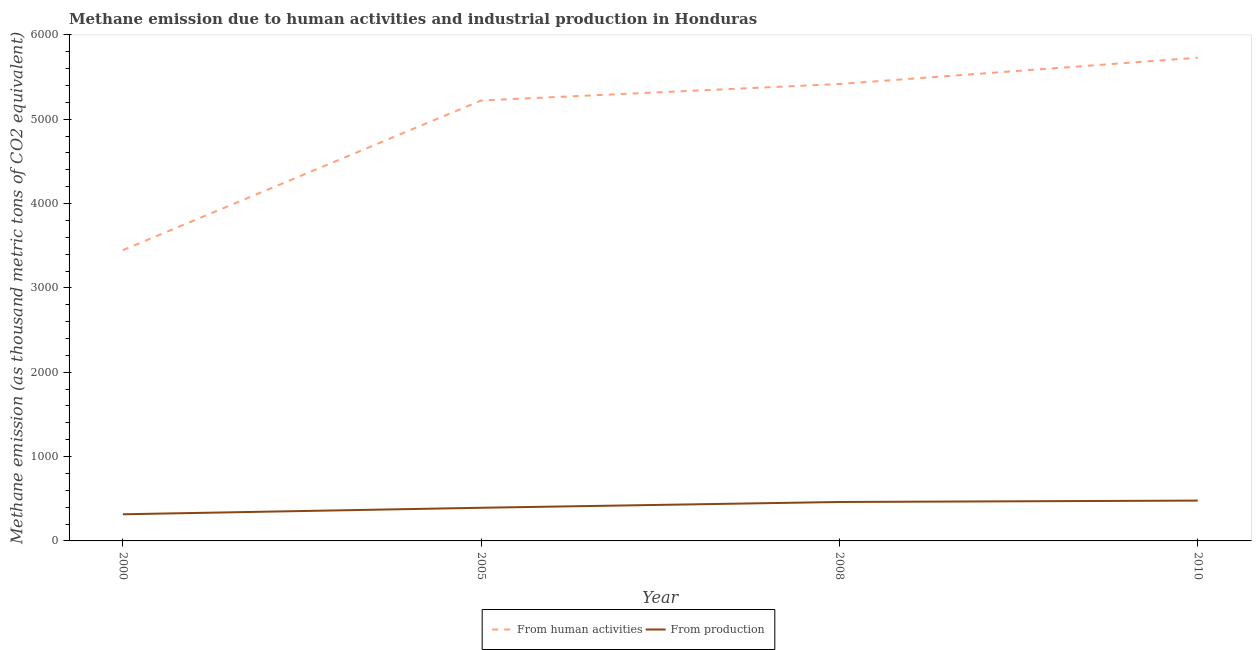How many different coloured lines are there?
Make the answer very short. 2. Does the line corresponding to amount of emissions generated from industries intersect with the line corresponding to amount of emissions from human activities?
Offer a very short reply. No. What is the amount of emissions from human activities in 2010?
Provide a short and direct response. 5729.7. Across all years, what is the maximum amount of emissions from human activities?
Give a very brief answer. 5729.7. Across all years, what is the minimum amount of emissions from human activities?
Offer a very short reply. 3447.7. In which year was the amount of emissions generated from industries minimum?
Offer a terse response. 2000. What is the total amount of emissions from human activities in the graph?
Offer a very short reply. 1.98e+04. What is the difference between the amount of emissions generated from industries in 2005 and that in 2008?
Ensure brevity in your answer.  -68.5. What is the difference between the amount of emissions from human activities in 2000 and the amount of emissions generated from industries in 2005?
Provide a succinct answer. 3054.5. What is the average amount of emissions from human activities per year?
Your answer should be compact. 4954.5. In the year 2010, what is the difference between the amount of emissions generated from industries and amount of emissions from human activities?
Offer a terse response. -5251.6. What is the ratio of the amount of emissions from human activities in 2000 to that in 2005?
Make the answer very short. 0.66. Is the amount of emissions from human activities in 2000 less than that in 2010?
Offer a very short reply. Yes. Is the difference between the amount of emissions from human activities in 2005 and 2010 greater than the difference between the amount of emissions generated from industries in 2005 and 2010?
Give a very brief answer. No. What is the difference between the highest and the second highest amount of emissions generated from industries?
Ensure brevity in your answer.  16.4. What is the difference between the highest and the lowest amount of emissions from human activities?
Ensure brevity in your answer.  2282. Is the amount of emissions generated from industries strictly less than the amount of emissions from human activities over the years?
Provide a succinct answer. Yes. How many lines are there?
Keep it short and to the point. 2. How many years are there in the graph?
Your response must be concise. 4. Are the values on the major ticks of Y-axis written in scientific E-notation?
Keep it short and to the point. No. Does the graph contain any zero values?
Offer a very short reply. No. Where does the legend appear in the graph?
Your response must be concise. Bottom center. How many legend labels are there?
Give a very brief answer. 2. How are the legend labels stacked?
Offer a very short reply. Horizontal. What is the title of the graph?
Your answer should be very brief. Methane emission due to human activities and industrial production in Honduras. Does "Quality of trade" appear as one of the legend labels in the graph?
Give a very brief answer. No. What is the label or title of the X-axis?
Keep it short and to the point. Year. What is the label or title of the Y-axis?
Give a very brief answer. Methane emission (as thousand metric tons of CO2 equivalent). What is the Methane emission (as thousand metric tons of CO2 equivalent) of From human activities in 2000?
Provide a succinct answer. 3447.7. What is the Methane emission (as thousand metric tons of CO2 equivalent) of From production in 2000?
Offer a terse response. 315.9. What is the Methane emission (as thousand metric tons of CO2 equivalent) in From human activities in 2005?
Your answer should be very brief. 5222.6. What is the Methane emission (as thousand metric tons of CO2 equivalent) in From production in 2005?
Your answer should be compact. 393.2. What is the Methane emission (as thousand metric tons of CO2 equivalent) in From human activities in 2008?
Keep it short and to the point. 5418. What is the Methane emission (as thousand metric tons of CO2 equivalent) of From production in 2008?
Make the answer very short. 461.7. What is the Methane emission (as thousand metric tons of CO2 equivalent) in From human activities in 2010?
Give a very brief answer. 5729.7. What is the Methane emission (as thousand metric tons of CO2 equivalent) in From production in 2010?
Offer a terse response. 478.1. Across all years, what is the maximum Methane emission (as thousand metric tons of CO2 equivalent) in From human activities?
Offer a very short reply. 5729.7. Across all years, what is the maximum Methane emission (as thousand metric tons of CO2 equivalent) of From production?
Your response must be concise. 478.1. Across all years, what is the minimum Methane emission (as thousand metric tons of CO2 equivalent) in From human activities?
Offer a very short reply. 3447.7. Across all years, what is the minimum Methane emission (as thousand metric tons of CO2 equivalent) in From production?
Your answer should be compact. 315.9. What is the total Methane emission (as thousand metric tons of CO2 equivalent) of From human activities in the graph?
Ensure brevity in your answer.  1.98e+04. What is the total Methane emission (as thousand metric tons of CO2 equivalent) of From production in the graph?
Offer a terse response. 1648.9. What is the difference between the Methane emission (as thousand metric tons of CO2 equivalent) in From human activities in 2000 and that in 2005?
Offer a very short reply. -1774.9. What is the difference between the Methane emission (as thousand metric tons of CO2 equivalent) in From production in 2000 and that in 2005?
Offer a very short reply. -77.3. What is the difference between the Methane emission (as thousand metric tons of CO2 equivalent) of From human activities in 2000 and that in 2008?
Your response must be concise. -1970.3. What is the difference between the Methane emission (as thousand metric tons of CO2 equivalent) of From production in 2000 and that in 2008?
Offer a very short reply. -145.8. What is the difference between the Methane emission (as thousand metric tons of CO2 equivalent) in From human activities in 2000 and that in 2010?
Ensure brevity in your answer.  -2282. What is the difference between the Methane emission (as thousand metric tons of CO2 equivalent) of From production in 2000 and that in 2010?
Make the answer very short. -162.2. What is the difference between the Methane emission (as thousand metric tons of CO2 equivalent) of From human activities in 2005 and that in 2008?
Offer a terse response. -195.4. What is the difference between the Methane emission (as thousand metric tons of CO2 equivalent) in From production in 2005 and that in 2008?
Provide a short and direct response. -68.5. What is the difference between the Methane emission (as thousand metric tons of CO2 equivalent) of From human activities in 2005 and that in 2010?
Offer a terse response. -507.1. What is the difference between the Methane emission (as thousand metric tons of CO2 equivalent) of From production in 2005 and that in 2010?
Your answer should be very brief. -84.9. What is the difference between the Methane emission (as thousand metric tons of CO2 equivalent) of From human activities in 2008 and that in 2010?
Your answer should be compact. -311.7. What is the difference between the Methane emission (as thousand metric tons of CO2 equivalent) of From production in 2008 and that in 2010?
Make the answer very short. -16.4. What is the difference between the Methane emission (as thousand metric tons of CO2 equivalent) of From human activities in 2000 and the Methane emission (as thousand metric tons of CO2 equivalent) of From production in 2005?
Your response must be concise. 3054.5. What is the difference between the Methane emission (as thousand metric tons of CO2 equivalent) in From human activities in 2000 and the Methane emission (as thousand metric tons of CO2 equivalent) in From production in 2008?
Give a very brief answer. 2986. What is the difference between the Methane emission (as thousand metric tons of CO2 equivalent) of From human activities in 2000 and the Methane emission (as thousand metric tons of CO2 equivalent) of From production in 2010?
Provide a short and direct response. 2969.6. What is the difference between the Methane emission (as thousand metric tons of CO2 equivalent) in From human activities in 2005 and the Methane emission (as thousand metric tons of CO2 equivalent) in From production in 2008?
Your answer should be very brief. 4760.9. What is the difference between the Methane emission (as thousand metric tons of CO2 equivalent) in From human activities in 2005 and the Methane emission (as thousand metric tons of CO2 equivalent) in From production in 2010?
Keep it short and to the point. 4744.5. What is the difference between the Methane emission (as thousand metric tons of CO2 equivalent) of From human activities in 2008 and the Methane emission (as thousand metric tons of CO2 equivalent) of From production in 2010?
Provide a short and direct response. 4939.9. What is the average Methane emission (as thousand metric tons of CO2 equivalent) of From human activities per year?
Offer a very short reply. 4954.5. What is the average Methane emission (as thousand metric tons of CO2 equivalent) in From production per year?
Offer a very short reply. 412.23. In the year 2000, what is the difference between the Methane emission (as thousand metric tons of CO2 equivalent) in From human activities and Methane emission (as thousand metric tons of CO2 equivalent) in From production?
Provide a short and direct response. 3131.8. In the year 2005, what is the difference between the Methane emission (as thousand metric tons of CO2 equivalent) in From human activities and Methane emission (as thousand metric tons of CO2 equivalent) in From production?
Ensure brevity in your answer.  4829.4. In the year 2008, what is the difference between the Methane emission (as thousand metric tons of CO2 equivalent) of From human activities and Methane emission (as thousand metric tons of CO2 equivalent) of From production?
Give a very brief answer. 4956.3. In the year 2010, what is the difference between the Methane emission (as thousand metric tons of CO2 equivalent) in From human activities and Methane emission (as thousand metric tons of CO2 equivalent) in From production?
Your answer should be very brief. 5251.6. What is the ratio of the Methane emission (as thousand metric tons of CO2 equivalent) in From human activities in 2000 to that in 2005?
Offer a very short reply. 0.66. What is the ratio of the Methane emission (as thousand metric tons of CO2 equivalent) of From production in 2000 to that in 2005?
Provide a succinct answer. 0.8. What is the ratio of the Methane emission (as thousand metric tons of CO2 equivalent) in From human activities in 2000 to that in 2008?
Give a very brief answer. 0.64. What is the ratio of the Methane emission (as thousand metric tons of CO2 equivalent) of From production in 2000 to that in 2008?
Your answer should be very brief. 0.68. What is the ratio of the Methane emission (as thousand metric tons of CO2 equivalent) of From human activities in 2000 to that in 2010?
Provide a succinct answer. 0.6. What is the ratio of the Methane emission (as thousand metric tons of CO2 equivalent) of From production in 2000 to that in 2010?
Make the answer very short. 0.66. What is the ratio of the Methane emission (as thousand metric tons of CO2 equivalent) of From human activities in 2005 to that in 2008?
Your response must be concise. 0.96. What is the ratio of the Methane emission (as thousand metric tons of CO2 equivalent) of From production in 2005 to that in 2008?
Provide a succinct answer. 0.85. What is the ratio of the Methane emission (as thousand metric tons of CO2 equivalent) of From human activities in 2005 to that in 2010?
Offer a very short reply. 0.91. What is the ratio of the Methane emission (as thousand metric tons of CO2 equivalent) of From production in 2005 to that in 2010?
Keep it short and to the point. 0.82. What is the ratio of the Methane emission (as thousand metric tons of CO2 equivalent) in From human activities in 2008 to that in 2010?
Offer a very short reply. 0.95. What is the ratio of the Methane emission (as thousand metric tons of CO2 equivalent) of From production in 2008 to that in 2010?
Provide a short and direct response. 0.97. What is the difference between the highest and the second highest Methane emission (as thousand metric tons of CO2 equivalent) of From human activities?
Your answer should be compact. 311.7. What is the difference between the highest and the second highest Methane emission (as thousand metric tons of CO2 equivalent) in From production?
Offer a terse response. 16.4. What is the difference between the highest and the lowest Methane emission (as thousand metric tons of CO2 equivalent) in From human activities?
Offer a very short reply. 2282. What is the difference between the highest and the lowest Methane emission (as thousand metric tons of CO2 equivalent) in From production?
Your answer should be very brief. 162.2. 